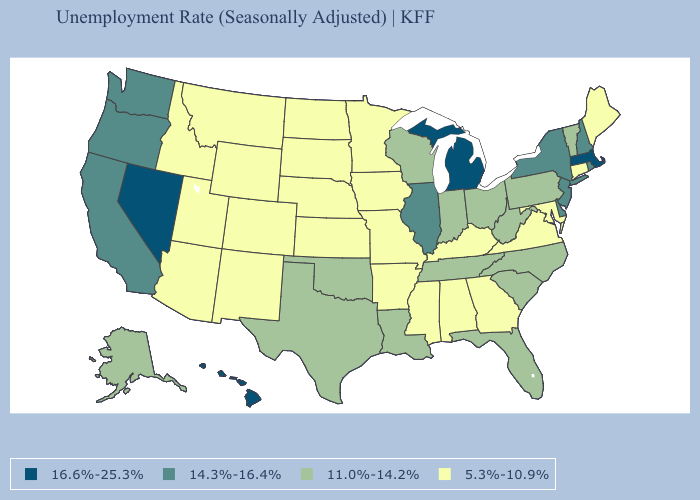Name the states that have a value in the range 14.3%-16.4%?
Answer briefly. California, Delaware, Illinois, New Hampshire, New Jersey, New York, Oregon, Rhode Island, Washington. Does Texas have the lowest value in the USA?
Be succinct. No. What is the value of Pennsylvania?
Give a very brief answer. 11.0%-14.2%. Name the states that have a value in the range 16.6%-25.3%?
Concise answer only. Hawaii, Massachusetts, Michigan, Nevada. Among the states that border Minnesota , which have the lowest value?
Give a very brief answer. Iowa, North Dakota, South Dakota. Name the states that have a value in the range 11.0%-14.2%?
Quick response, please. Alaska, Florida, Indiana, Louisiana, North Carolina, Ohio, Oklahoma, Pennsylvania, South Carolina, Tennessee, Texas, Vermont, West Virginia, Wisconsin. What is the value of Arizona?
Concise answer only. 5.3%-10.9%. Is the legend a continuous bar?
Answer briefly. No. Does North Dakota have the highest value in the USA?
Concise answer only. No. Does Texas have the lowest value in the USA?
Give a very brief answer. No. What is the value of Alaska?
Give a very brief answer. 11.0%-14.2%. What is the value of New Mexico?
Keep it brief. 5.3%-10.9%. Is the legend a continuous bar?
Keep it brief. No. Does the map have missing data?
Concise answer only. No. Does Mississippi have a lower value than Nebraska?
Quick response, please. No. 